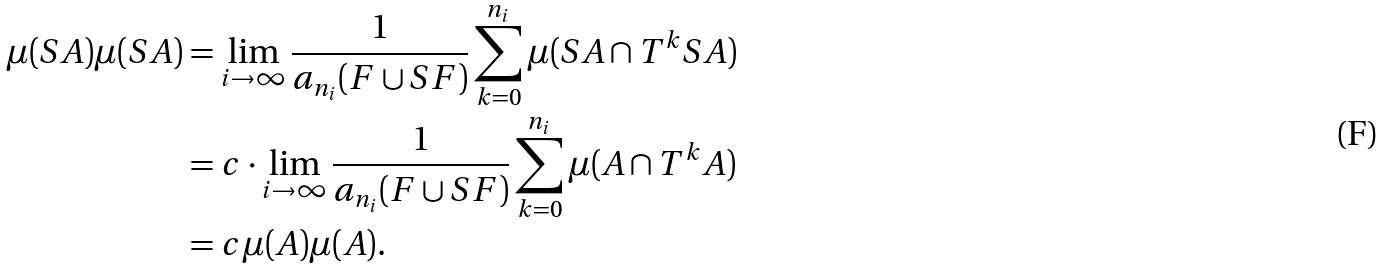<formula> <loc_0><loc_0><loc_500><loc_500>\mu ( S A ) \mu ( S A ) & = \lim _ { i \rightarrow \infty } \frac { 1 } { a _ { n _ { i } } ( F \cup S F ) } \sum _ { k = 0 } ^ { n _ { i } } \mu ( S A \cap T ^ { k } S A ) \\ & = c \cdot \lim _ { i \rightarrow \infty } \frac { 1 } { a _ { n _ { i } } ( F \cup S F ) } \sum _ { k = 0 } ^ { n _ { i } } \mu ( A \cap T ^ { k } A ) \\ & = c \mu ( A ) \mu ( A ) .</formula> 